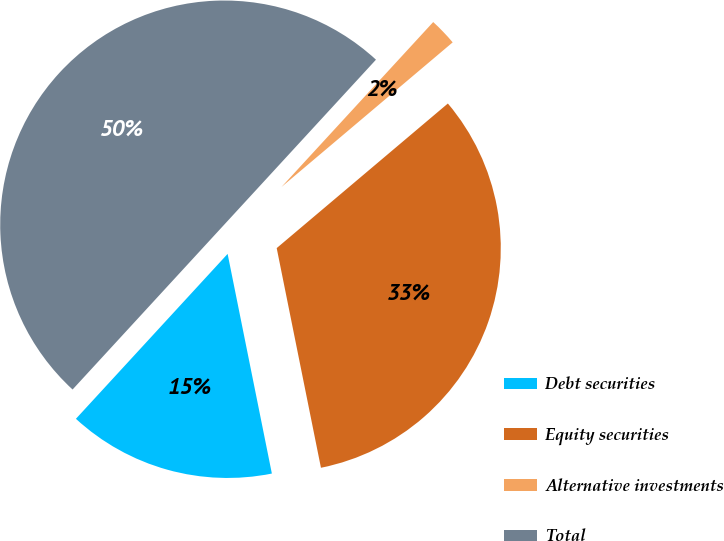Convert chart to OTSL. <chart><loc_0><loc_0><loc_500><loc_500><pie_chart><fcel>Debt securities<fcel>Equity securities<fcel>Alternative investments<fcel>Total<nl><fcel>15.0%<fcel>33.0%<fcel>2.0%<fcel>50.0%<nl></chart> 